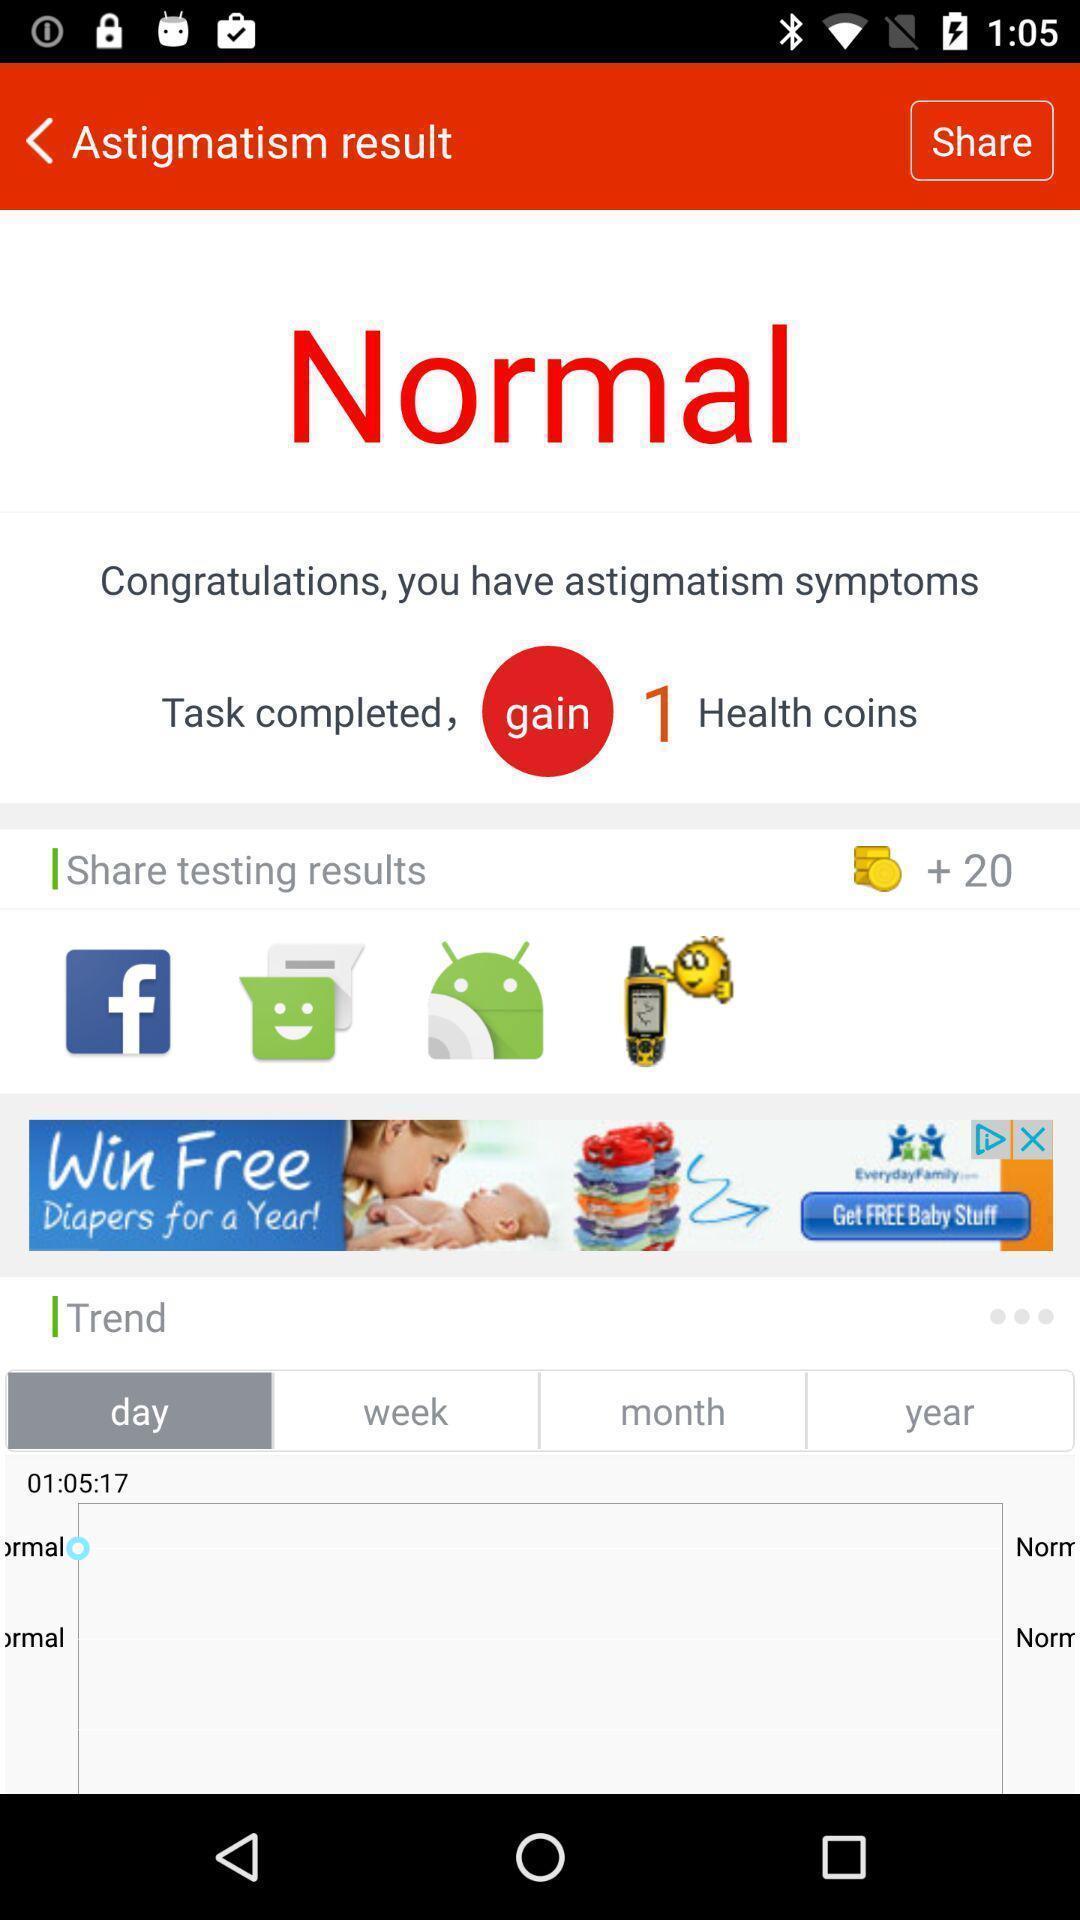Summarize the main components in this picture. Page of a testing app showing result with sharing options. 